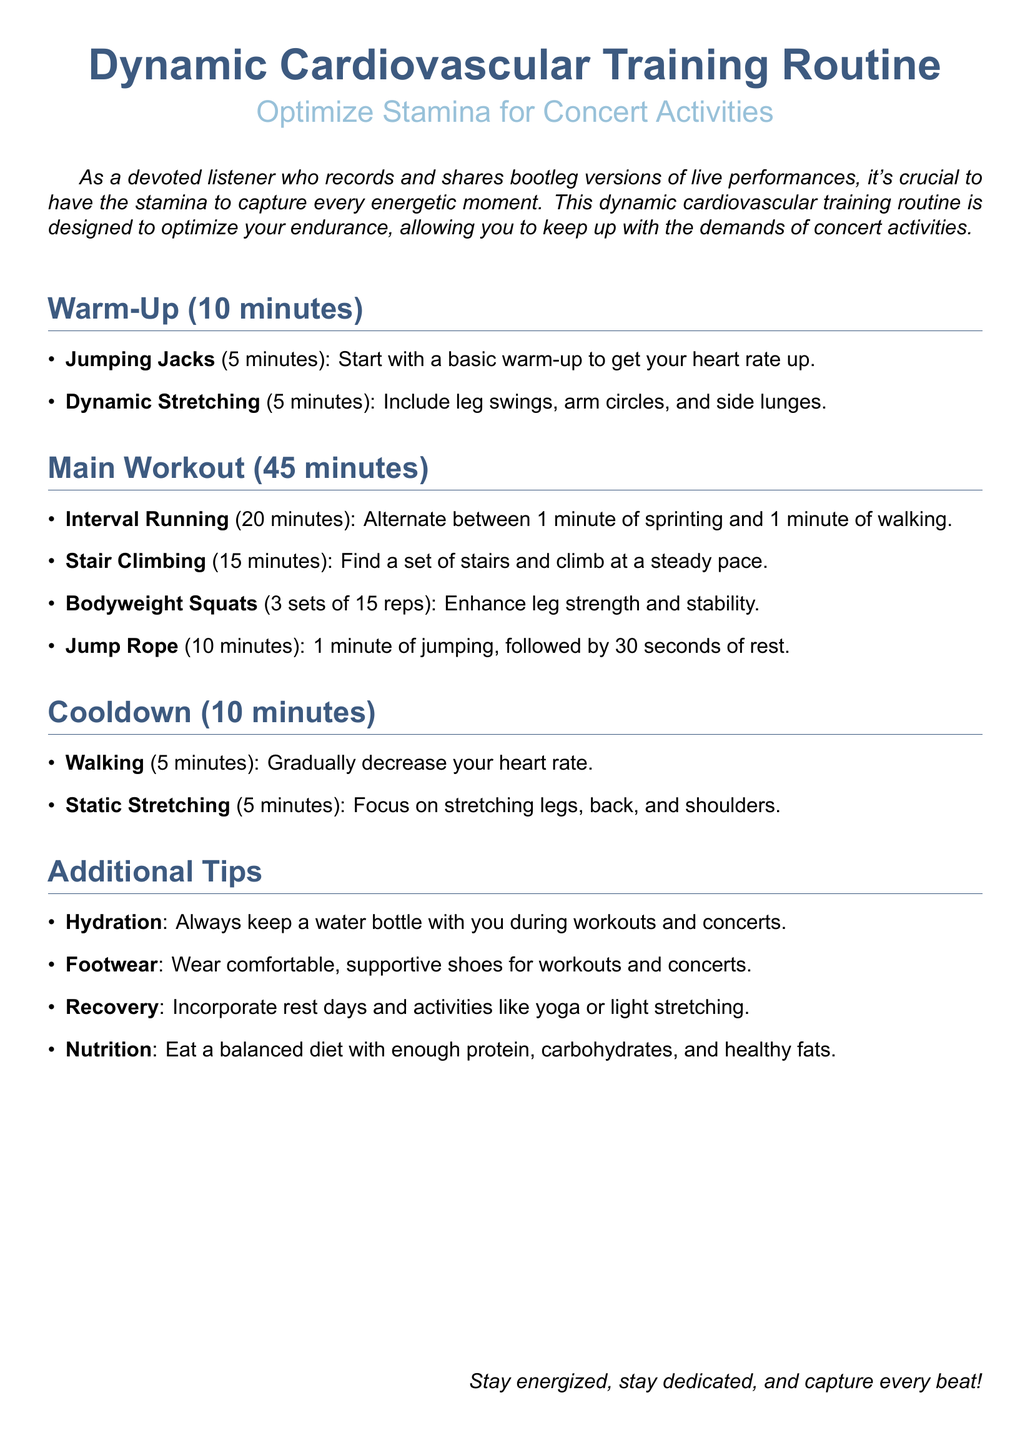What is the total duration of the warm-up? The warm-up section states that it lasts 10 minutes.
Answer: 10 minutes How long is the main workout? The main workout section specifies that it is 45 minutes long.
Answer: 45 minutes What exercise requires stair climbing? The main workout includes stair climbing as one of the activities.
Answer: Stair Climbing How many sets of bodyweight squats are included? The document mentions performing 3 sets of bodyweight squats in the main workout.
Answer: 3 sets What is one key element to include in recovery? The additional tips recommend incorporating rest days for recovery.
Answer: Rest days What is the purpose of the dynamic cardiovascular training routine? The document states that it is designed to optimize endurance for concert activities.
Answer: Optimize endurance How long should you spend doing jumping jacks? The warm-up section specifies that jumping jacks should be done for 5 minutes.
Answer: 5 minutes What type of nutritional advice is given? The additional tips section mentions the importance of eating a balanced diet.
Answer: Balanced diet 